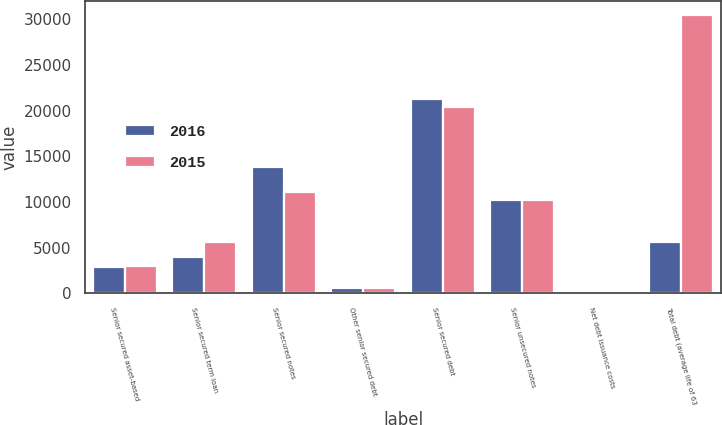Convert chart. <chart><loc_0><loc_0><loc_500><loc_500><stacked_bar_chart><ecel><fcel>Senior secured asset-based<fcel>Senior secured term loan<fcel>Senior secured notes<fcel>Other senior secured debt<fcel>Senior secured debt<fcel>Senior unsecured notes<fcel>Net debt issuance costs<fcel>Total debt (average life of 63<nl><fcel>2016<fcel>2920<fcel>3981<fcel>13800<fcel>593<fcel>21294<fcel>10252<fcel>170<fcel>5639<nl><fcel>2015<fcel>3030<fcel>5639<fcel>11100<fcel>634<fcel>20403<fcel>10252<fcel>167<fcel>30488<nl></chart> 